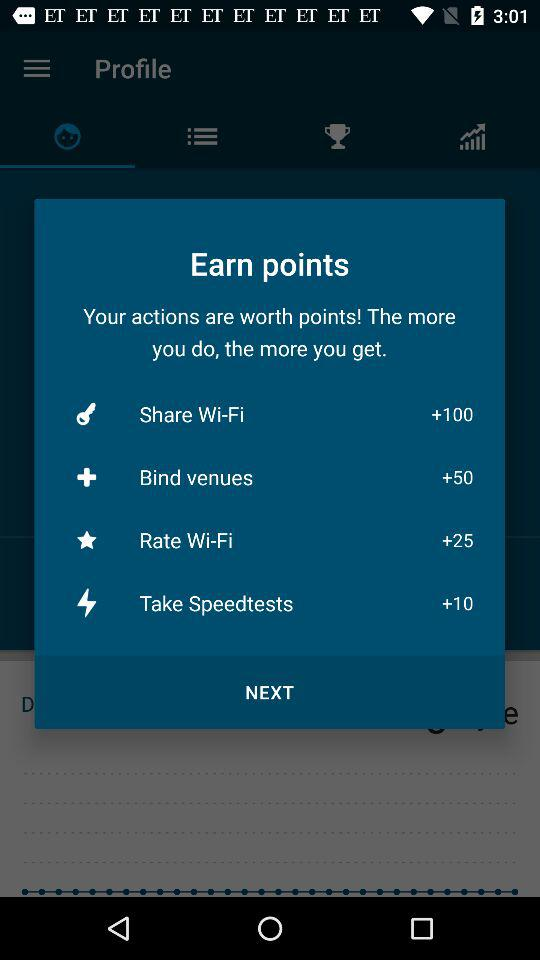How many points are offered for sharing Wi-Fi? 100 